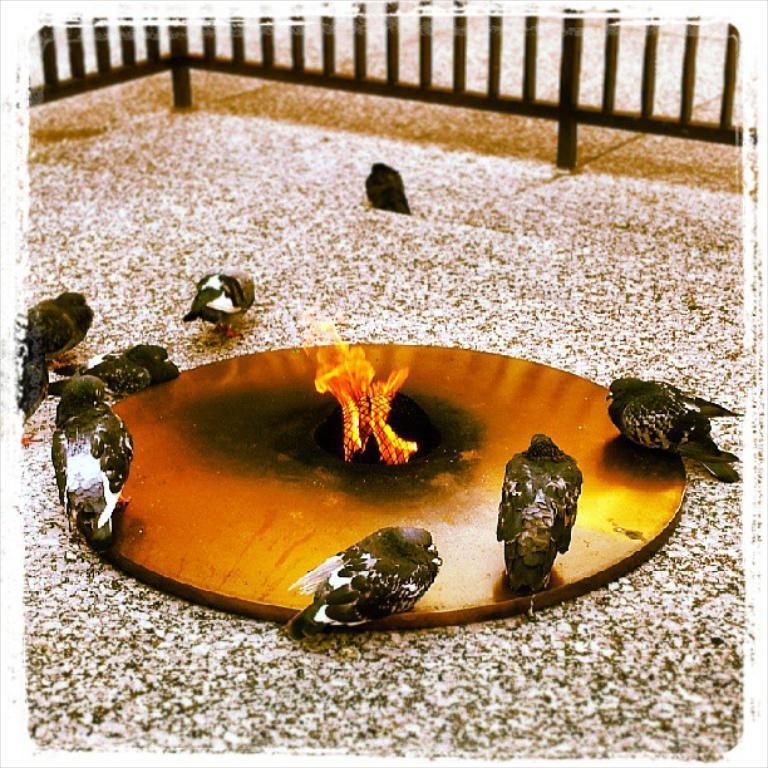Can you describe this image briefly? In this image we can see there are a few birds on the object, In the middle of the object there is a flame. At the top of the image there is a fence. 